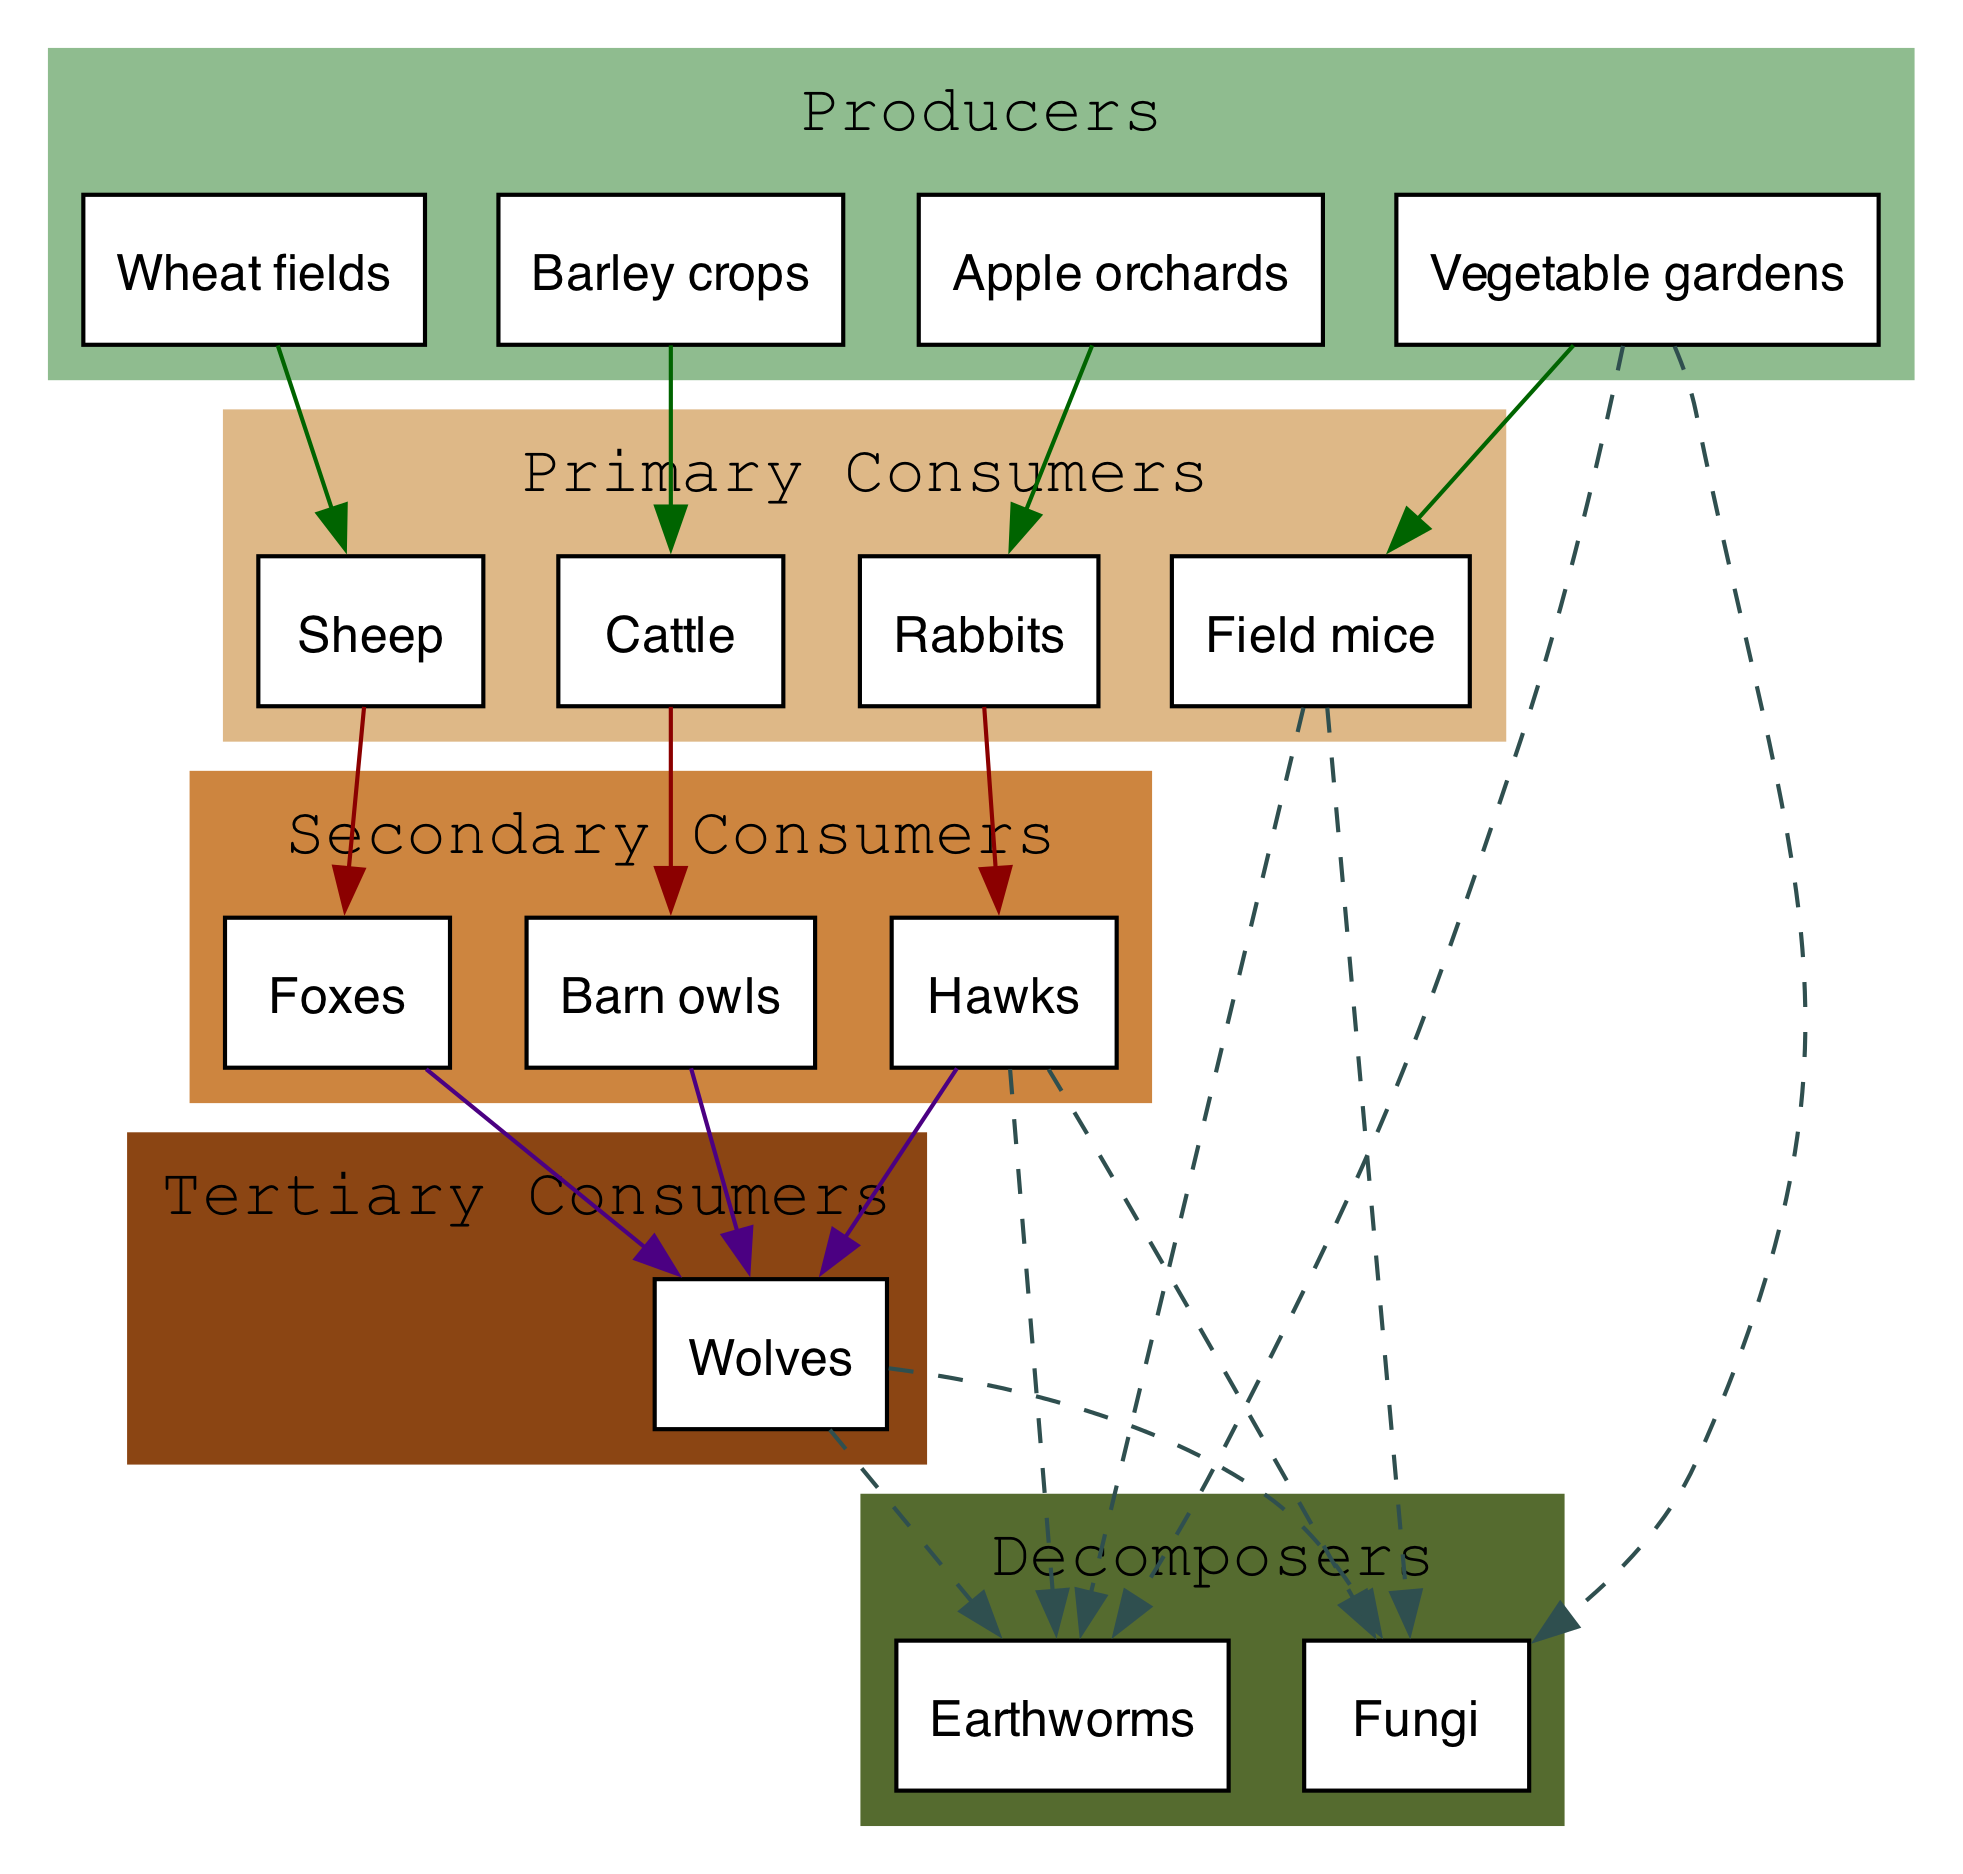What are the primary consumers in the food chain? By looking at the 'primary consumers' cluster in the diagram, we can list the species grouped there. They include sheep, cattle, rabbits, and field mice.
Answer: Sheep, cattle, rabbits, field mice How many secondary consumers are present? The 'secondary consumers' cluster lists the animals that feed on primary consumers. The diagram shows three secondary consumers: foxes, barn owls, and hawks.
Answer: 3 Which livestock feeds on wheat fields? To find this answer, we identify the livestock in the primary consumers section and see which one is connected to the 'wheat fields' producer. The diagram clearly shows that sheep are fed by wheat fields.
Answer: Sheep What is the role of earthworms in the ecosystem? Earthworms are part of the 'decomposers' category in the diagram. They help break down dead organic matter, turning it into nutrients for the soil, which supports plant growth.
Answer: Decomposers Which animal is at the top of the food chain? By examining the 'tertiary consumers' section, we see that there is one animal listed: wolves. This indicates they are the apex predators in this food chain.
Answer: Wolves How many producers are represented in the diagram? The 'producers' cluster contains four items: wheat fields, barley crops, apple orchards, and vegetable gardens. Counting these gives us the total number of producers.
Answer: 4 What do decomposers like fungi do in the ecosystem? The role of fungi, as represented in the diagram under 'decomposers,' is to break down organic material and recycle nutrients back into the soil. This is essential for maintaining soil health and supporting new plant growth.
Answer: Decomposers Which secondary consumer has multiple connections in the food chain? The barn owl is one of the secondary consumers that can be seen connected to multiple primary consumers in the diagram, indicating it has a varied diet.
Answer: Barn owl What connects the primary consumers to the secondary consumers? Looking at the arrows in the diagram, we see that the primary consumers are connected to the secondary consumers through direct predation; this indicates a feeding relationship where secondary consumers prey on primary consumers.
Answer: Arrows (predation) 